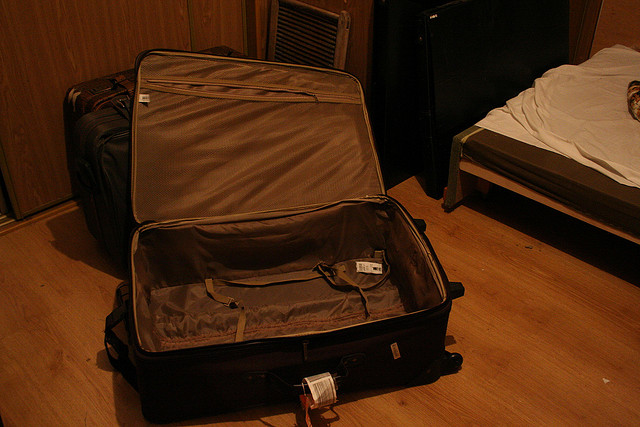<image>What kind of clothes are in the suitcase? There are no clothes in the suitcase. What kind of clothes are in the suitcase? There are no clothes in the suitcase. 